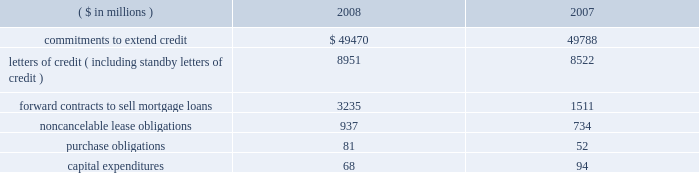Notes to consolidated financial statements fifth third bancorp 81 vii held by the trust vii bear a fixed rate of interest of 8.875% ( 8.875 % ) until may 15 , 2058 .
Thereafter , the notes pay a floating rate at three-month libor plus 500 bp .
The bancorp entered into an interest rate swap to convert $ 275 million of the fixed-rate debt into floating .
At december 31 , 2008 , the rate paid on the swap was 6.05% ( 6.05 % ) .
The jsn vii may be redeemed at the option of the bancorp on or after may 15 , 2013 , or in certain other limited circumstances , at a redemption price of 100% ( 100 % ) of the principal amount plus accrued but unpaid interest .
All redemptions are subject to certain conditions and generally require approval by the federal reserve board .
Subsidiary long-term borrowings the senior fixed-rate bank notes due from 2009 to 2019 are the obligations of a subsidiary bank .
The maturities of the face value of the senior fixed-rate bank notes are as follows : $ 36 million in 2009 , $ 800 million in 2010 and $ 275 million in 2019 .
The bancorp entered into interest rate swaps to convert $ 1.1 billion of the fixed-rate debt into floating rates .
At december 31 , 2008 , the rates paid on these swaps were 2.19% ( 2.19 % ) on $ 800 million and 2.20% ( 2.20 % ) on $ 275 million .
In august 2008 , $ 500 million of senior fixed-rate bank notes issued in july of 2003 matured and were paid .
These long-term bank notes were issued to third-party investors at a fixed rate of 3.375% ( 3.375 % ) .
The senior floating-rate bank notes due in 2013 are the obligations of a subsidiary bank .
The notes pay a floating rate at three-month libor plus 11 bp .
The senior extendable notes consist of $ 797 million that currently pay interest at three-month libor plus 4 bp and $ 400 million that pay at the federal funds open rate plus 12 bp .
The subordinated fixed-rate bank notes due in 2015 are the obligations of a subsidiary bank .
The bancorp entered into interest rate swaps to convert the fixed-rate debt into floating rate .
At december 31 , 2008 , the weighted-average rate paid on the swaps was 3.29% ( 3.29 % ) .
The junior subordinated floating-rate bank notes due in 2032 and 2033 were assumed by a bancorp subsidiary as part of the acquisition of crown in november 2007 .
Two of the notes pay floating at three-month libor plus 310 and 325 bp .
The third note pays floating at six-month libor plus 370 bp .
The three-month libor plus 290 bp and the three-month libor plus 279 bp junior subordinated debentures due in 2033 and 2034 , respectively , were assumed by a subsidiary of the bancorp in connection with the acquisition of first national bank .
The obligations were issued to fnb statutory trusts i and ii , respectively .
The junior subordinated floating-rate bank notes due in 2035 were assumed by a bancorp subsidiary as part of the acquisition of first charter in may 2008 .
The obligations were issued to first charter capital trust i and ii , respectively .
The notes of first charter capital trust i and ii pay floating at three-month libor plus 169 bp and 142 bp , respectively .
The bancorp has fully and unconditionally guaranteed all obligations under the acquired trust preferred securities .
At december 31 , 2008 , fhlb advances have rates ranging from 0% ( 0 % ) to 8.34% ( 8.34 % ) , with interest payable monthly .
The advances are secured by certain residential mortgage loans and securities totaling $ 8.6 billion .
At december 31 , 2008 , $ 2.5 billion of fhlb advances are floating rate .
The bancorp has interest rate caps , with a notional of $ 1.5 billion , held against its fhlb advance borrowings .
The $ 3.6 billion in advances mature as follows : $ 1.5 billion in 2009 , $ 1 million in 2010 , $ 2 million in 2011 , $ 1 billion in 2012 and $ 1.1 billion in 2013 and thereafter .
Medium-term senior notes and subordinated bank notes with maturities ranging from one year to 30 years can be issued by two subsidiary banks , of which $ 3.8 billion was outstanding at december 31 , 2008 with $ 16.2 billion available for future issuance .
There were no other medium-term senior notes outstanding on either of the two subsidiary banks as of december 31 , 2008 .
15 .
Commitments , contingent liabilities and guarantees the bancorp , in the normal course of business , enters into financial instruments and various agreements to meet the financing needs of its customers .
The bancorp also enters into certain transactions and agreements to manage its interest rate and prepayment risks , provide funding , equipment and locations for its operations and invest in its communities .
These instruments and agreements involve , to varying degrees , elements of credit risk , counterparty risk and market risk in excess of the amounts recognized in the bancorp 2019s consolidated balance sheets .
Creditworthiness for all instruments and agreements is evaluated on a case-by-case basis in accordance with the bancorp 2019s credit policies .
The bancorp 2019s significant commitments , contingent liabilities and guarantees in excess of the amounts recognized in the consolidated balance sheets are summarized as follows : commitments the bancorp has certain commitments to make future payments under contracts .
A summary of significant commitments at december 31: .
Commitments to extend credit are agreements to lend , typically having fixed expiration dates or other termination clauses that may require payment of a fee .
Since many of the commitments to extend credit may expire without being drawn upon , the total commitment amounts do not necessarily represent future cash flow requirements .
The bancorp is exposed to credit risk in the event of nonperformance for the amount of the contract .
Fixed-rate commitments are also subject to market risk resulting from fluctuations in interest rates and the bancorp 2019s exposure is limited to the replacement value of those commitments .
As of december 31 , 2008 and 2007 , the bancorp had a reserve for unfunded commitments totaling $ 195 million and $ 95 million , respectively , included in other liabilities in the consolidated balance sheets .
Standby and commercial letters of credit are conditional commitments issued to guarantee the performance of a customer to a third party .
At december 31 , 2008 , approximately $ 3.3 billion of letters of credit expire within one year ( including $ 57 million issued on behalf of commercial customers to facilitate trade payments in dollars and foreign currencies ) , $ 5.3 billion expire between one to five years and $ 0.4 billion expire thereafter .
Standby letters of credit are considered guarantees in accordance with fasb interpretation no .
45 , 201cguarantor 2019s accounting and disclosure requirements for guarantees , including indirect guarantees of indebtedness of others 201d ( fin 45 ) .
At december 31 , 2008 , the reserve related to these standby letters of credit was $ 3 million .
Approximately 66% ( 66 % ) and 70% ( 70 % ) of the total standby letters of credit were secured as of december 31 , 2008 and 2007 , respectively .
In the event of nonperformance by the customers , the bancorp has rights to the underlying collateral , which can include commercial real estate , physical plant and property , inventory , receivables , cash and marketable securities .
The bancorp monitors the credit risk associated with the standby letters of credit using the same dual risk rating system utilized for .
What is the percentage change in the balance of noncancelable lease obligations from 2007 to 2008? 
Computations: ((937 - 734) / 734)
Answer: 0.27657. 